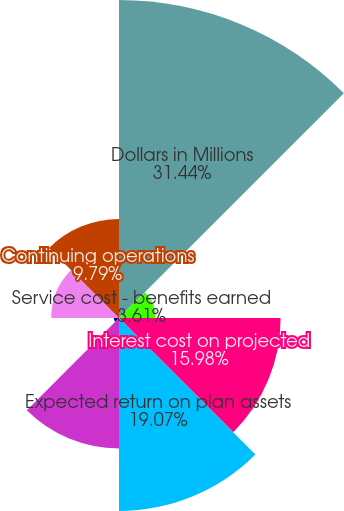Convert chart. <chart><loc_0><loc_0><loc_500><loc_500><pie_chart><fcel>Dollars in Millions<fcel>Service cost - benefits earned<fcel>Interest cost on projected<fcel>Expected return on plan assets<fcel>Amortization of net actuarial<fcel>Net periodic benefit cost<fcel>Total net periodic benefit<fcel>Continuing operations<nl><fcel>31.44%<fcel>3.61%<fcel>15.98%<fcel>19.07%<fcel>12.89%<fcel>0.52%<fcel>6.7%<fcel>9.79%<nl></chart> 